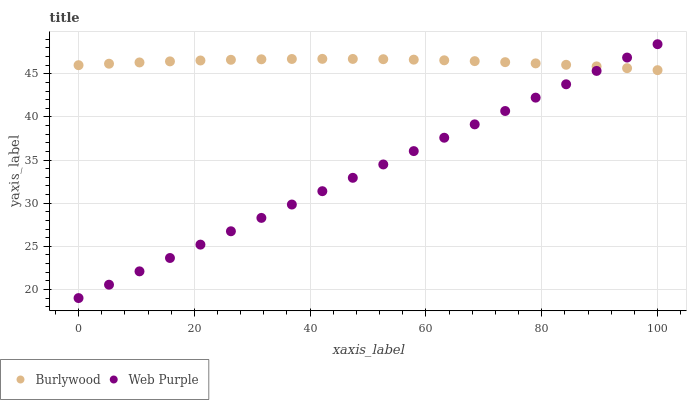Does Web Purple have the minimum area under the curve?
Answer yes or no. Yes. Does Burlywood have the maximum area under the curve?
Answer yes or no. Yes. Does Web Purple have the maximum area under the curve?
Answer yes or no. No. Is Web Purple the smoothest?
Answer yes or no. Yes. Is Burlywood the roughest?
Answer yes or no. Yes. Is Web Purple the roughest?
Answer yes or no. No. Does Web Purple have the lowest value?
Answer yes or no. Yes. Does Web Purple have the highest value?
Answer yes or no. Yes. Does Burlywood intersect Web Purple?
Answer yes or no. Yes. Is Burlywood less than Web Purple?
Answer yes or no. No. Is Burlywood greater than Web Purple?
Answer yes or no. No. 